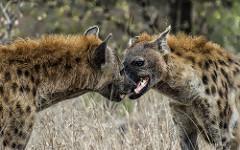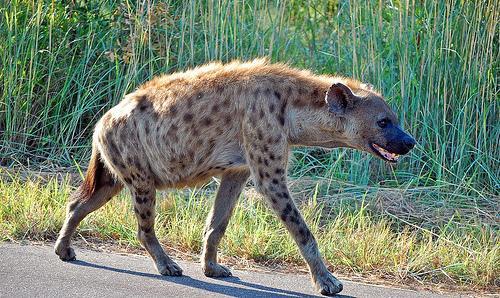The first image is the image on the left, the second image is the image on the right. Examine the images to the left and right. Is the description "The left image contains no more than two hyenas." accurate? Answer yes or no. Yes. 